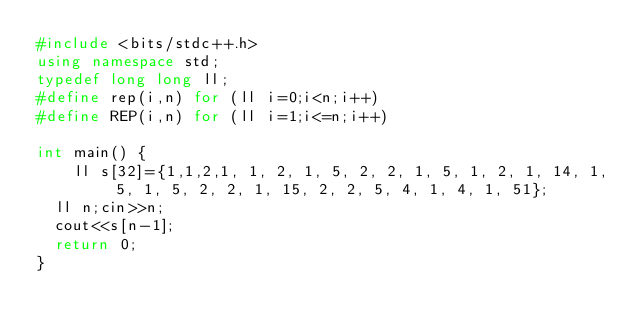Convert code to text. <code><loc_0><loc_0><loc_500><loc_500><_C++_>#include <bits/stdc++.h>
using namespace std;
typedef long long ll;
#define rep(i,n) for (ll i=0;i<n;i++)
#define REP(i,n) for (ll i=1;i<=n;i++)

int main() {
    ll s[32]={1,1,2,1, 1, 2, 1, 5, 2, 2, 1, 5, 1, 2, 1, 14, 1, 5, 1, 5, 2, 2, 1, 15, 2, 2, 5, 4, 1, 4, 1, 51};
  ll n;cin>>n;
  cout<<s[n-1];
  return 0;
}</code> 